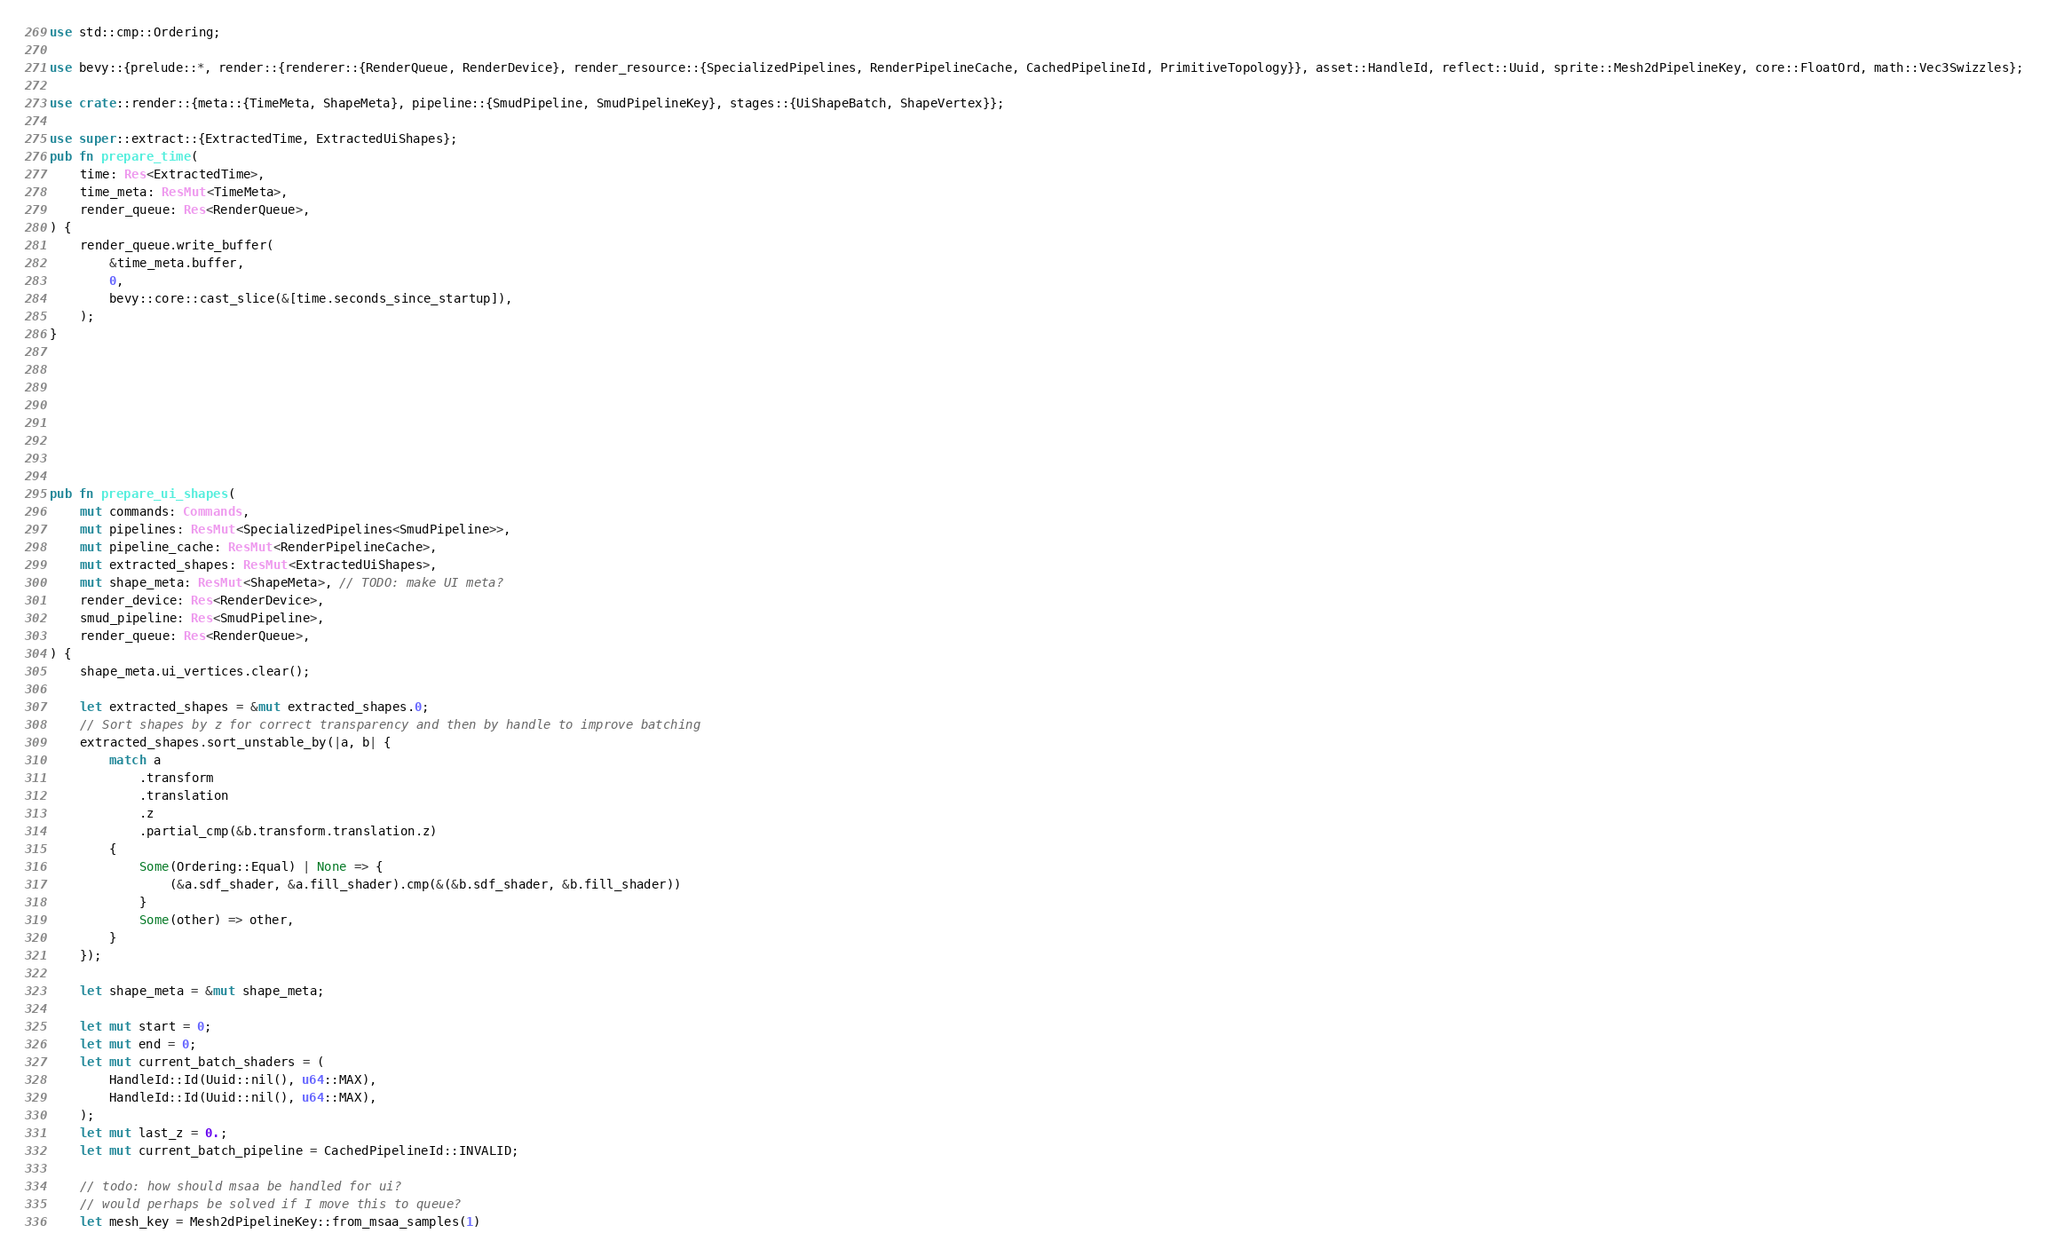<code> <loc_0><loc_0><loc_500><loc_500><_Rust_>use std::cmp::Ordering;

use bevy::{prelude::*, render::{renderer::{RenderQueue, RenderDevice}, render_resource::{SpecializedPipelines, RenderPipelineCache, CachedPipelineId, PrimitiveTopology}}, asset::HandleId, reflect::Uuid, sprite::Mesh2dPipelineKey, core::FloatOrd, math::Vec3Swizzles};

use crate::render::{meta::{TimeMeta, ShapeMeta}, pipeline::{SmudPipeline, SmudPipelineKey}, stages::{UiShapeBatch, ShapeVertex}};

use super::extract::{ExtractedTime, ExtractedUiShapes};
pub fn prepare_time(
    time: Res<ExtractedTime>,
    time_meta: ResMut<TimeMeta>,
    render_queue: Res<RenderQueue>,
) {
    render_queue.write_buffer(
        &time_meta.buffer,
        0,
        bevy::core::cast_slice(&[time.seconds_since_startup]),
    );
}








pub fn prepare_ui_shapes(
    mut commands: Commands,
    mut pipelines: ResMut<SpecializedPipelines<SmudPipeline>>,
    mut pipeline_cache: ResMut<RenderPipelineCache>,
    mut extracted_shapes: ResMut<ExtractedUiShapes>,
    mut shape_meta: ResMut<ShapeMeta>, // TODO: make UI meta?
    render_device: Res<RenderDevice>,
    smud_pipeline: Res<SmudPipeline>,
    render_queue: Res<RenderQueue>,
) {
    shape_meta.ui_vertices.clear();

    let extracted_shapes = &mut extracted_shapes.0;
    // Sort shapes by z for correct transparency and then by handle to improve batching
    extracted_shapes.sort_unstable_by(|a, b| {
        match a
            .transform
            .translation
            .z
            .partial_cmp(&b.transform.translation.z)
        {
            Some(Ordering::Equal) | None => {
                (&a.sdf_shader, &a.fill_shader).cmp(&(&b.sdf_shader, &b.fill_shader))
            }
            Some(other) => other,
        }
    });

    let shape_meta = &mut shape_meta;

    let mut start = 0;
    let mut end = 0;
    let mut current_batch_shaders = (
        HandleId::Id(Uuid::nil(), u64::MAX),
        HandleId::Id(Uuid::nil(), u64::MAX),
    );
    let mut last_z = 0.;
    let mut current_batch_pipeline = CachedPipelineId::INVALID;

    // todo: how should msaa be handled for ui?
    // would perhaps be solved if I move this to queue?
    let mesh_key = Mesh2dPipelineKey::from_msaa_samples(1)</code> 